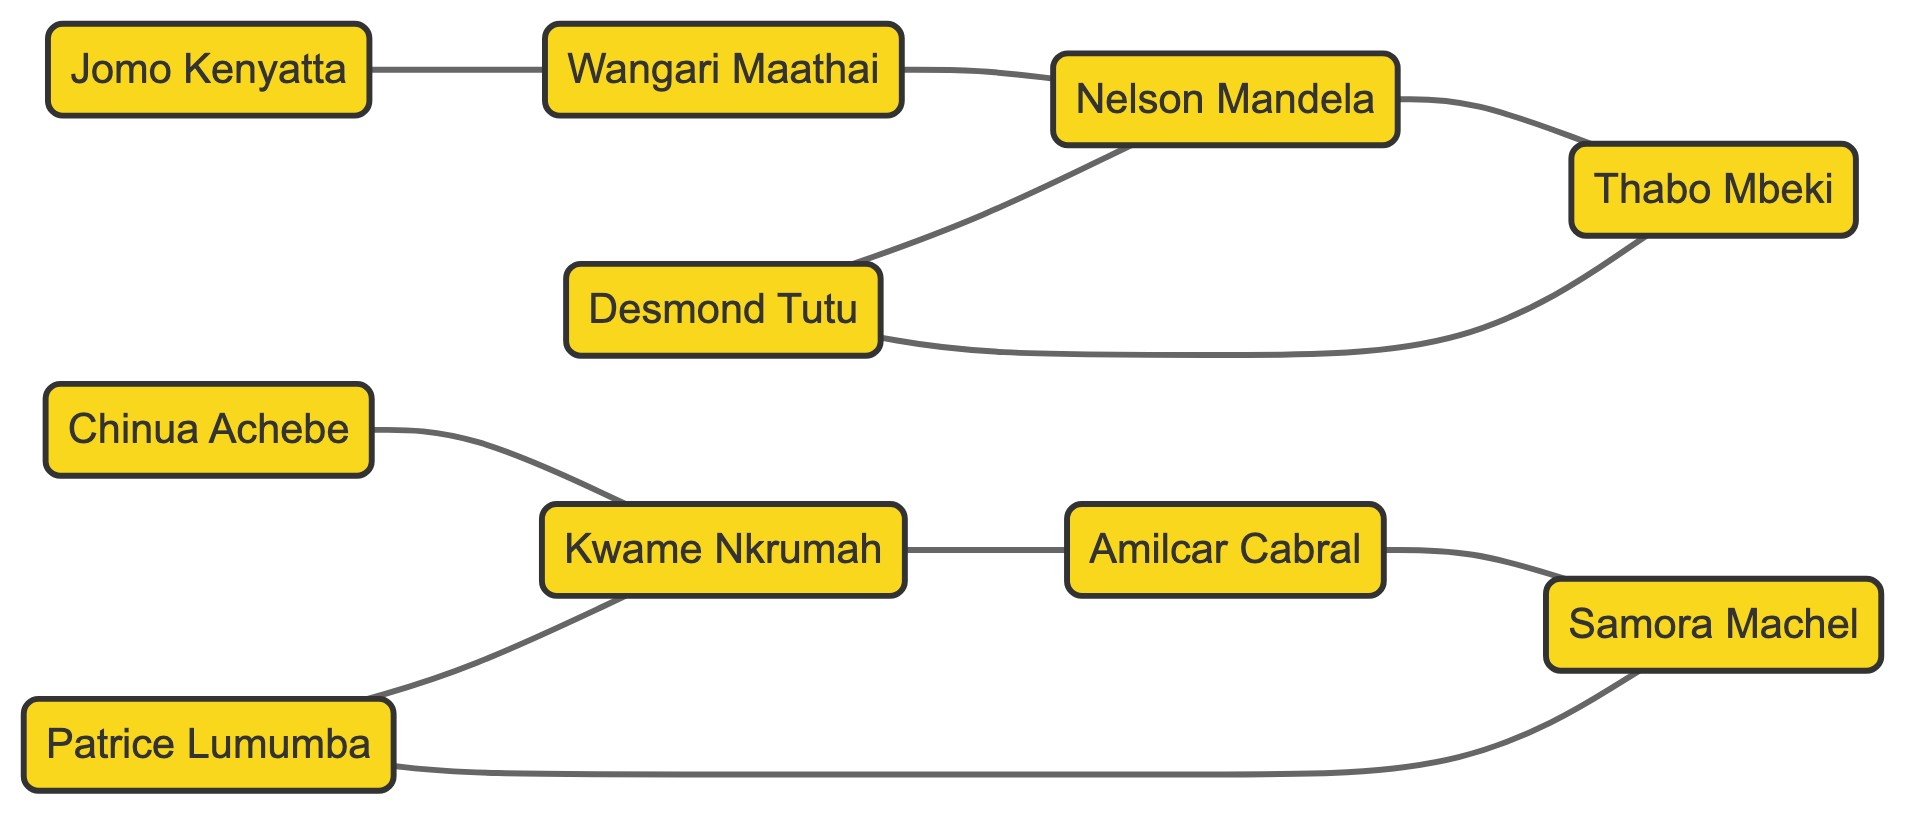What is the total number of activists in the network? By counting the number of unique nodes listed, I find there are 10 individuals representing activists.
Answer: 10 Which two activists are directly connected to Nelson Mandela? Looking at the edges connected to Nelson Mandela, I see that Wangari Maathai and Thabo Mbeki are directly linked to him.
Answer: Wangari Maathai, Thabo Mbeki Who is connected to both Kwame Nkrumah and Amilcar Cabral? Examining the edges, I observe that Kwame Nkrumah is connected to Amilcar Cabral directly, making Kwame Nkrumah the common connection point.
Answer: Kwame Nkrumah How many total edges are present in the network? By counting all the edges listed, I determine there are 10 connections between the activists.
Answer: 10 Which activist is a direct connection between Wangari Maathai and Jomo Kenyatta? Observing the edges, I confirm that Wangari Maathai is connected to Jomo Kenyatta, and there is no other node involved in that direct connection.
Answer: Wangari Maathai Which activist has connections to both Patrice Lumumba and Amilcar Cabral? By analyzing the edges, it is evident that Samora Machel connects to both Patrice Lumumba and Amilcar Cabral through their respective edges.
Answer: Samora Machel Which activist is most central in terms of connections? Assessing the connections, I see that Nelson Mandela is directly connected to the most number of activists, namely 3, indicating his centrality in the network.
Answer: Nelson Mandela How many activists are directly connected to Desmond Tutu? Looking closely at the edges, I find that Desmond Tutu has 2 direct connections: Nelson Mandela and Thabo Mbeki.
Answer: 2 What is the relationship pattern between Kwame Nkrumah, Patrice Lumumba, and their connections? Following the edges, both Kwame Nkrumah and Patrice Lumumba are connected to Amilcar Cabral, yet each has another direct edge showing distinct relationships, with Kwame Nkrumah being linked to Chinua Achebe and Patrice Lumumba to Samora Machel.
Answer: Interconnected through Amilcar Cabral 